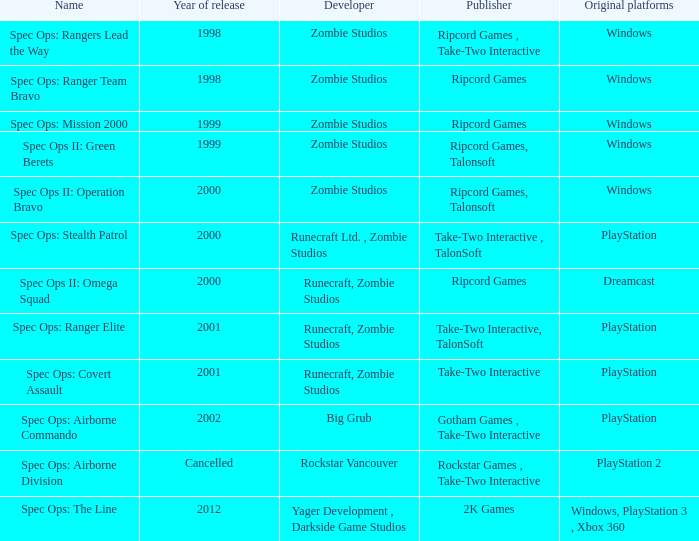Which publisher is responsible for releasing a game for the original dreamcast platform in 2000? Ripcord Games. 